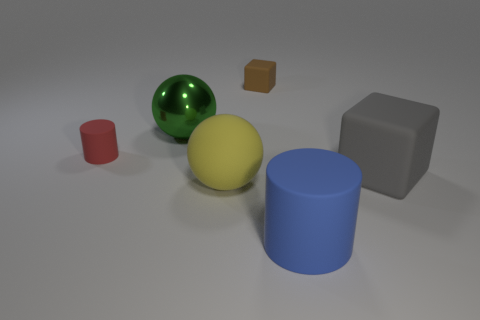Subtract all brown blocks. How many blocks are left? 1 Subtract all balls. How many objects are left? 4 Subtract 2 spheres. How many spheres are left? 0 Subtract all cyan cubes. How many green balls are left? 1 Subtract all blocks. Subtract all green shiny things. How many objects are left? 3 Add 3 small rubber blocks. How many small rubber blocks are left? 4 Add 6 big blue shiny objects. How many big blue shiny objects exist? 6 Add 3 large yellow rubber objects. How many objects exist? 9 Subtract 0 cyan cubes. How many objects are left? 6 Subtract all brown balls. Subtract all blue cylinders. How many balls are left? 2 